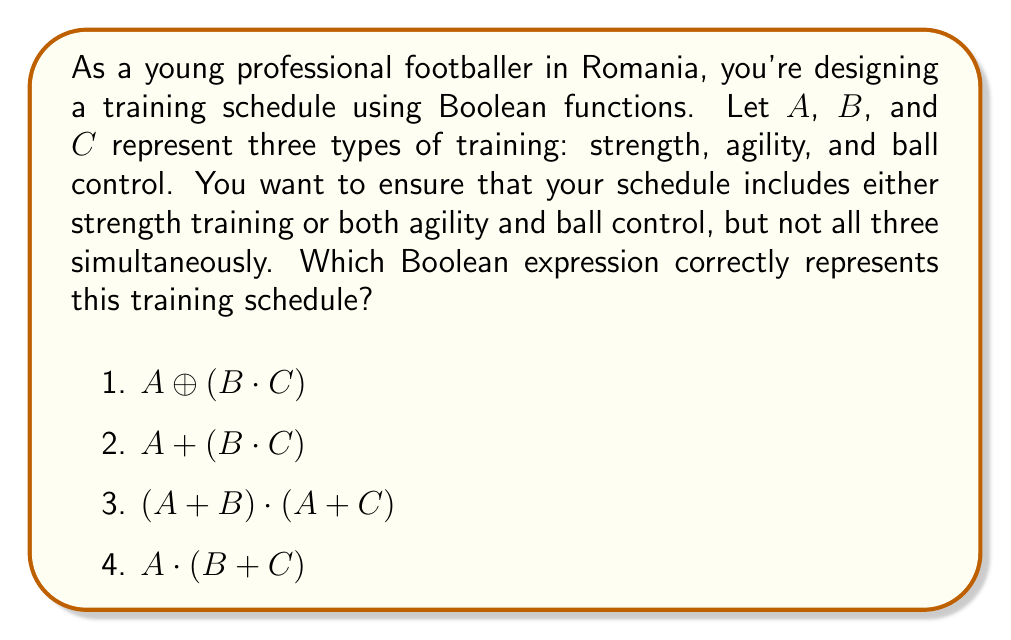Show me your answer to this math problem. Let's break this down step-by-step:

1) First, let's understand what the question is asking:
   - We need either strength training (A) OR both agility (B) and ball control (C)
   - We don't want all three types of training simultaneously

2) Let's examine each option:

   1) $A \oplus (B \cdot C)$: 
      This is the XOR operation between A and (B AND C). It means either A is true or (B AND C) is true, but not both. This matches our requirements.

   2) $A + (B \cdot C)$: 
      This is the OR operation between A and (B AND C). It allows for A to be true, (B AND C) to be true, or both to be true. This doesn't meet our requirement of not having all three simultaneously.

   3) $(A + B) \cdot (A + C)$: 
      This expands to $A + (B \cdot C)$, which is the same as option 2 and doesn't meet our requirements.

   4) $A \cdot (B + C)$: 
      This means A must be true, and either B or C (or both) must be true. This doesn't match our requirements at all.

3) Therefore, the correct answer is option 1: $A \oplus (B \cdot C)$

   This Boolean expression ensures that:
   - If A is true (strength training), then B and C cannot both be true
   - If B and C are both true (agility and ball control), then A must be false
   - It's not possible for A, B, and C to all be true simultaneously
Answer: $A \oplus (B \cdot C)$ 